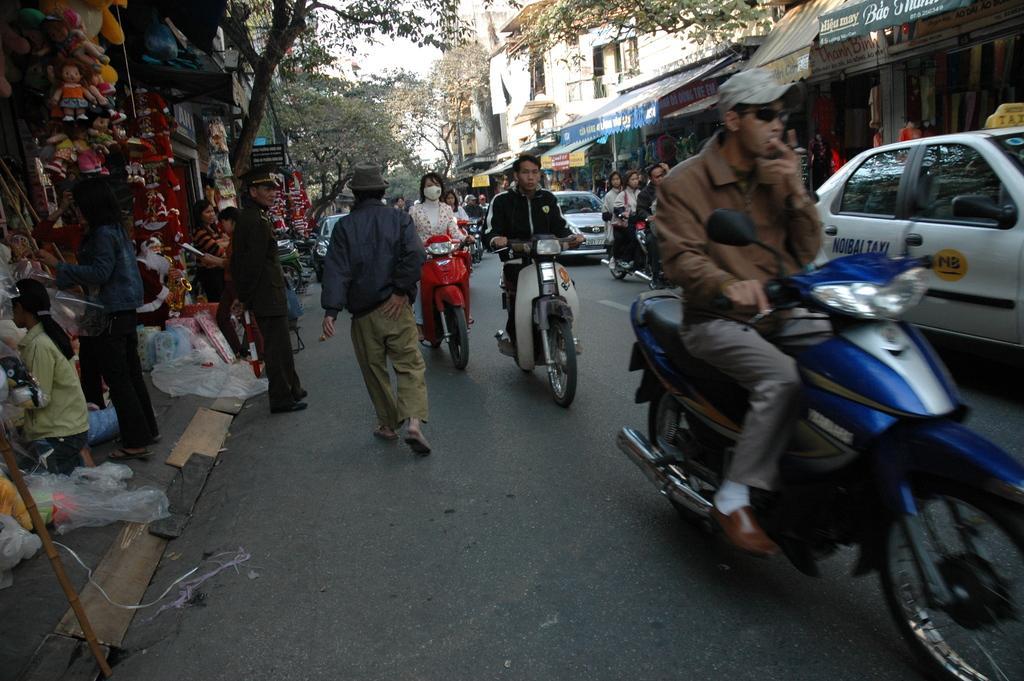Could you give a brief overview of what you see in this image? This picture is taken on a road. There are many people walking, riding motorbikes and cars on the road. To the left corner of the image there are toy shops and people are standing at it. To the right corner of the image there are many shops. In the background there is a building, tree and sky. 